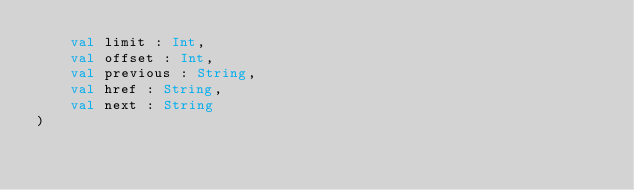<code> <loc_0><loc_0><loc_500><loc_500><_Kotlin_>    val limit : Int,
    val offset : Int,
    val previous : String,
    val href : String,
    val next : String
)</code> 